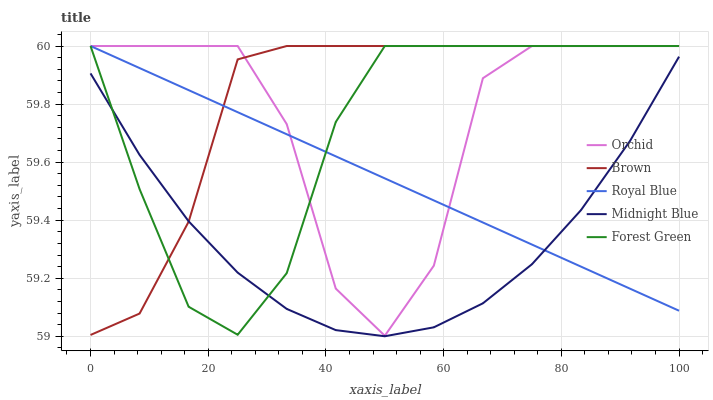Does Midnight Blue have the minimum area under the curve?
Answer yes or no. Yes. Does Brown have the maximum area under the curve?
Answer yes or no. Yes. Does Forest Green have the minimum area under the curve?
Answer yes or no. No. Does Forest Green have the maximum area under the curve?
Answer yes or no. No. Is Royal Blue the smoothest?
Answer yes or no. Yes. Is Orchid the roughest?
Answer yes or no. Yes. Is Forest Green the smoothest?
Answer yes or no. No. Is Forest Green the roughest?
Answer yes or no. No. Does Midnight Blue have the lowest value?
Answer yes or no. Yes. Does Forest Green have the lowest value?
Answer yes or no. No. Does Orchid have the highest value?
Answer yes or no. Yes. Does Midnight Blue have the highest value?
Answer yes or no. No. Is Midnight Blue less than Orchid?
Answer yes or no. Yes. Is Orchid greater than Midnight Blue?
Answer yes or no. Yes. Does Forest Green intersect Brown?
Answer yes or no. Yes. Is Forest Green less than Brown?
Answer yes or no. No. Is Forest Green greater than Brown?
Answer yes or no. No. Does Midnight Blue intersect Orchid?
Answer yes or no. No. 